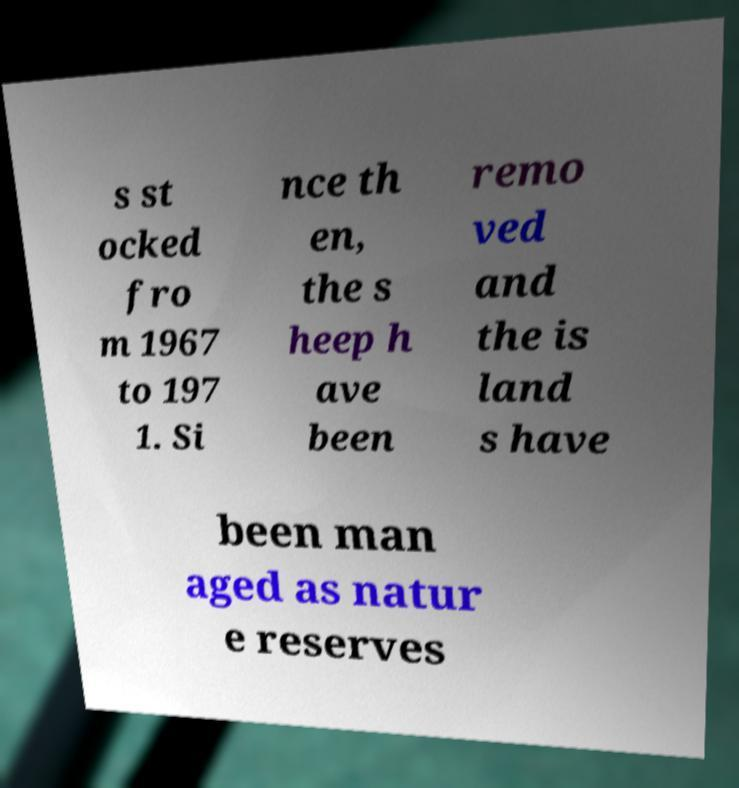For documentation purposes, I need the text within this image transcribed. Could you provide that? s st ocked fro m 1967 to 197 1. Si nce th en, the s heep h ave been remo ved and the is land s have been man aged as natur e reserves 